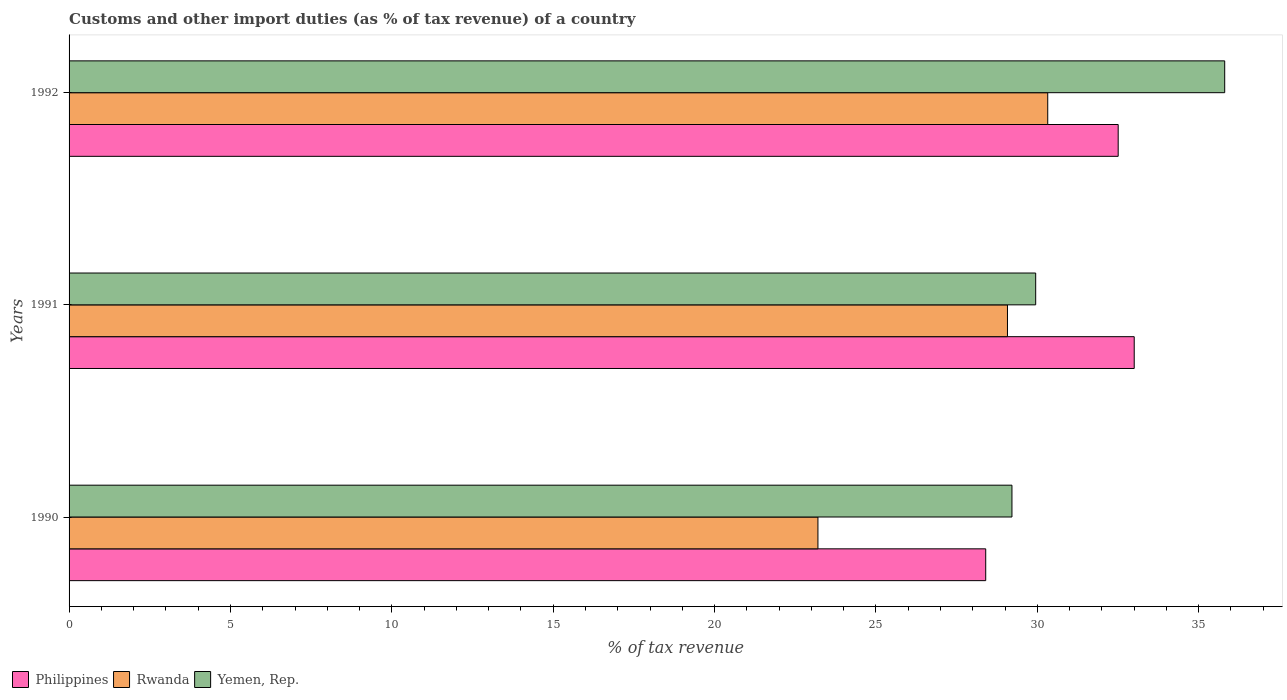How many different coloured bars are there?
Keep it short and to the point. 3. How many groups of bars are there?
Provide a succinct answer. 3. Are the number of bars on each tick of the Y-axis equal?
Offer a very short reply. Yes. How many bars are there on the 1st tick from the top?
Your answer should be compact. 3. How many bars are there on the 1st tick from the bottom?
Your answer should be very brief. 3. In how many cases, is the number of bars for a given year not equal to the number of legend labels?
Ensure brevity in your answer.  0. What is the percentage of tax revenue from customs in Yemen, Rep. in 1991?
Your answer should be compact. 29.95. Across all years, what is the maximum percentage of tax revenue from customs in Philippines?
Your response must be concise. 33. Across all years, what is the minimum percentage of tax revenue from customs in Rwanda?
Provide a succinct answer. 23.2. In which year was the percentage of tax revenue from customs in Yemen, Rep. maximum?
Offer a very short reply. 1992. What is the total percentage of tax revenue from customs in Philippines in the graph?
Your answer should be compact. 93.91. What is the difference between the percentage of tax revenue from customs in Rwanda in 1990 and that in 1991?
Provide a succinct answer. -5.87. What is the difference between the percentage of tax revenue from customs in Yemen, Rep. in 1990 and the percentage of tax revenue from customs in Rwanda in 1991?
Your answer should be compact. 0.14. What is the average percentage of tax revenue from customs in Yemen, Rep. per year?
Offer a very short reply. 31.66. In the year 1992, what is the difference between the percentage of tax revenue from customs in Rwanda and percentage of tax revenue from customs in Yemen, Rep.?
Provide a succinct answer. -5.48. What is the ratio of the percentage of tax revenue from customs in Yemen, Rep. in 1990 to that in 1991?
Give a very brief answer. 0.98. Is the percentage of tax revenue from customs in Philippines in 1990 less than that in 1991?
Provide a short and direct response. Yes. Is the difference between the percentage of tax revenue from customs in Rwanda in 1990 and 1992 greater than the difference between the percentage of tax revenue from customs in Yemen, Rep. in 1990 and 1992?
Make the answer very short. No. What is the difference between the highest and the second highest percentage of tax revenue from customs in Rwanda?
Your answer should be compact. 1.25. What is the difference between the highest and the lowest percentage of tax revenue from customs in Philippines?
Keep it short and to the point. 4.6. What does the 1st bar from the top in 1992 represents?
Ensure brevity in your answer.  Yemen, Rep. What does the 3rd bar from the bottom in 1992 represents?
Ensure brevity in your answer.  Yemen, Rep. Are all the bars in the graph horizontal?
Give a very brief answer. Yes. Are the values on the major ticks of X-axis written in scientific E-notation?
Offer a very short reply. No. Does the graph contain any zero values?
Make the answer very short. No. Does the graph contain grids?
Ensure brevity in your answer.  No. Where does the legend appear in the graph?
Ensure brevity in your answer.  Bottom left. What is the title of the graph?
Your answer should be very brief. Customs and other import duties (as % of tax revenue) of a country. What is the label or title of the X-axis?
Offer a terse response. % of tax revenue. What is the % of tax revenue of Philippines in 1990?
Provide a succinct answer. 28.4. What is the % of tax revenue in Rwanda in 1990?
Your response must be concise. 23.2. What is the % of tax revenue in Yemen, Rep. in 1990?
Your response must be concise. 29.21. What is the % of tax revenue in Philippines in 1991?
Give a very brief answer. 33. What is the % of tax revenue of Rwanda in 1991?
Provide a succinct answer. 29.08. What is the % of tax revenue in Yemen, Rep. in 1991?
Make the answer very short. 29.95. What is the % of tax revenue in Philippines in 1992?
Provide a succinct answer. 32.51. What is the % of tax revenue in Rwanda in 1992?
Keep it short and to the point. 30.32. What is the % of tax revenue of Yemen, Rep. in 1992?
Offer a terse response. 35.81. Across all years, what is the maximum % of tax revenue in Philippines?
Make the answer very short. 33. Across all years, what is the maximum % of tax revenue of Rwanda?
Give a very brief answer. 30.32. Across all years, what is the maximum % of tax revenue in Yemen, Rep.?
Your response must be concise. 35.81. Across all years, what is the minimum % of tax revenue in Philippines?
Keep it short and to the point. 28.4. Across all years, what is the minimum % of tax revenue of Rwanda?
Provide a short and direct response. 23.2. Across all years, what is the minimum % of tax revenue of Yemen, Rep.?
Offer a terse response. 29.21. What is the total % of tax revenue of Philippines in the graph?
Offer a terse response. 93.91. What is the total % of tax revenue of Rwanda in the graph?
Your answer should be very brief. 82.6. What is the total % of tax revenue in Yemen, Rep. in the graph?
Offer a very short reply. 94.97. What is the difference between the % of tax revenue in Philippines in 1990 and that in 1991?
Ensure brevity in your answer.  -4.6. What is the difference between the % of tax revenue of Rwanda in 1990 and that in 1991?
Your answer should be compact. -5.87. What is the difference between the % of tax revenue in Yemen, Rep. in 1990 and that in 1991?
Your answer should be very brief. -0.74. What is the difference between the % of tax revenue in Philippines in 1990 and that in 1992?
Your answer should be very brief. -4.1. What is the difference between the % of tax revenue in Rwanda in 1990 and that in 1992?
Give a very brief answer. -7.12. What is the difference between the % of tax revenue of Yemen, Rep. in 1990 and that in 1992?
Provide a short and direct response. -6.59. What is the difference between the % of tax revenue of Philippines in 1991 and that in 1992?
Offer a very short reply. 0.5. What is the difference between the % of tax revenue of Rwanda in 1991 and that in 1992?
Offer a very short reply. -1.25. What is the difference between the % of tax revenue of Yemen, Rep. in 1991 and that in 1992?
Make the answer very short. -5.86. What is the difference between the % of tax revenue of Philippines in 1990 and the % of tax revenue of Rwanda in 1991?
Your response must be concise. -0.67. What is the difference between the % of tax revenue of Philippines in 1990 and the % of tax revenue of Yemen, Rep. in 1991?
Your answer should be compact. -1.55. What is the difference between the % of tax revenue in Rwanda in 1990 and the % of tax revenue in Yemen, Rep. in 1991?
Your answer should be very brief. -6.75. What is the difference between the % of tax revenue in Philippines in 1990 and the % of tax revenue in Rwanda in 1992?
Offer a terse response. -1.92. What is the difference between the % of tax revenue of Philippines in 1990 and the % of tax revenue of Yemen, Rep. in 1992?
Provide a short and direct response. -7.4. What is the difference between the % of tax revenue in Rwanda in 1990 and the % of tax revenue in Yemen, Rep. in 1992?
Your answer should be very brief. -12.6. What is the difference between the % of tax revenue of Philippines in 1991 and the % of tax revenue of Rwanda in 1992?
Provide a succinct answer. 2.68. What is the difference between the % of tax revenue of Philippines in 1991 and the % of tax revenue of Yemen, Rep. in 1992?
Provide a short and direct response. -2.8. What is the difference between the % of tax revenue in Rwanda in 1991 and the % of tax revenue in Yemen, Rep. in 1992?
Provide a short and direct response. -6.73. What is the average % of tax revenue in Philippines per year?
Keep it short and to the point. 31.3. What is the average % of tax revenue in Rwanda per year?
Your answer should be very brief. 27.53. What is the average % of tax revenue of Yemen, Rep. per year?
Ensure brevity in your answer.  31.66. In the year 1990, what is the difference between the % of tax revenue in Philippines and % of tax revenue in Rwanda?
Provide a succinct answer. 5.2. In the year 1990, what is the difference between the % of tax revenue in Philippines and % of tax revenue in Yemen, Rep.?
Provide a short and direct response. -0.81. In the year 1990, what is the difference between the % of tax revenue in Rwanda and % of tax revenue in Yemen, Rep.?
Ensure brevity in your answer.  -6.01. In the year 1991, what is the difference between the % of tax revenue of Philippines and % of tax revenue of Rwanda?
Offer a very short reply. 3.93. In the year 1991, what is the difference between the % of tax revenue of Philippines and % of tax revenue of Yemen, Rep.?
Keep it short and to the point. 3.05. In the year 1991, what is the difference between the % of tax revenue in Rwanda and % of tax revenue in Yemen, Rep.?
Your response must be concise. -0.87. In the year 1992, what is the difference between the % of tax revenue of Philippines and % of tax revenue of Rwanda?
Keep it short and to the point. 2.18. In the year 1992, what is the difference between the % of tax revenue of Philippines and % of tax revenue of Yemen, Rep.?
Your answer should be very brief. -3.3. In the year 1992, what is the difference between the % of tax revenue of Rwanda and % of tax revenue of Yemen, Rep.?
Provide a succinct answer. -5.48. What is the ratio of the % of tax revenue in Philippines in 1990 to that in 1991?
Ensure brevity in your answer.  0.86. What is the ratio of the % of tax revenue in Rwanda in 1990 to that in 1991?
Ensure brevity in your answer.  0.8. What is the ratio of the % of tax revenue of Yemen, Rep. in 1990 to that in 1991?
Your response must be concise. 0.98. What is the ratio of the % of tax revenue in Philippines in 1990 to that in 1992?
Offer a very short reply. 0.87. What is the ratio of the % of tax revenue in Rwanda in 1990 to that in 1992?
Offer a very short reply. 0.77. What is the ratio of the % of tax revenue of Yemen, Rep. in 1990 to that in 1992?
Your answer should be very brief. 0.82. What is the ratio of the % of tax revenue in Philippines in 1991 to that in 1992?
Your answer should be very brief. 1.02. What is the ratio of the % of tax revenue in Rwanda in 1991 to that in 1992?
Offer a very short reply. 0.96. What is the ratio of the % of tax revenue in Yemen, Rep. in 1991 to that in 1992?
Provide a short and direct response. 0.84. What is the difference between the highest and the second highest % of tax revenue in Philippines?
Ensure brevity in your answer.  0.5. What is the difference between the highest and the second highest % of tax revenue in Rwanda?
Ensure brevity in your answer.  1.25. What is the difference between the highest and the second highest % of tax revenue of Yemen, Rep.?
Make the answer very short. 5.86. What is the difference between the highest and the lowest % of tax revenue in Philippines?
Offer a very short reply. 4.6. What is the difference between the highest and the lowest % of tax revenue in Rwanda?
Keep it short and to the point. 7.12. What is the difference between the highest and the lowest % of tax revenue of Yemen, Rep.?
Offer a terse response. 6.59. 